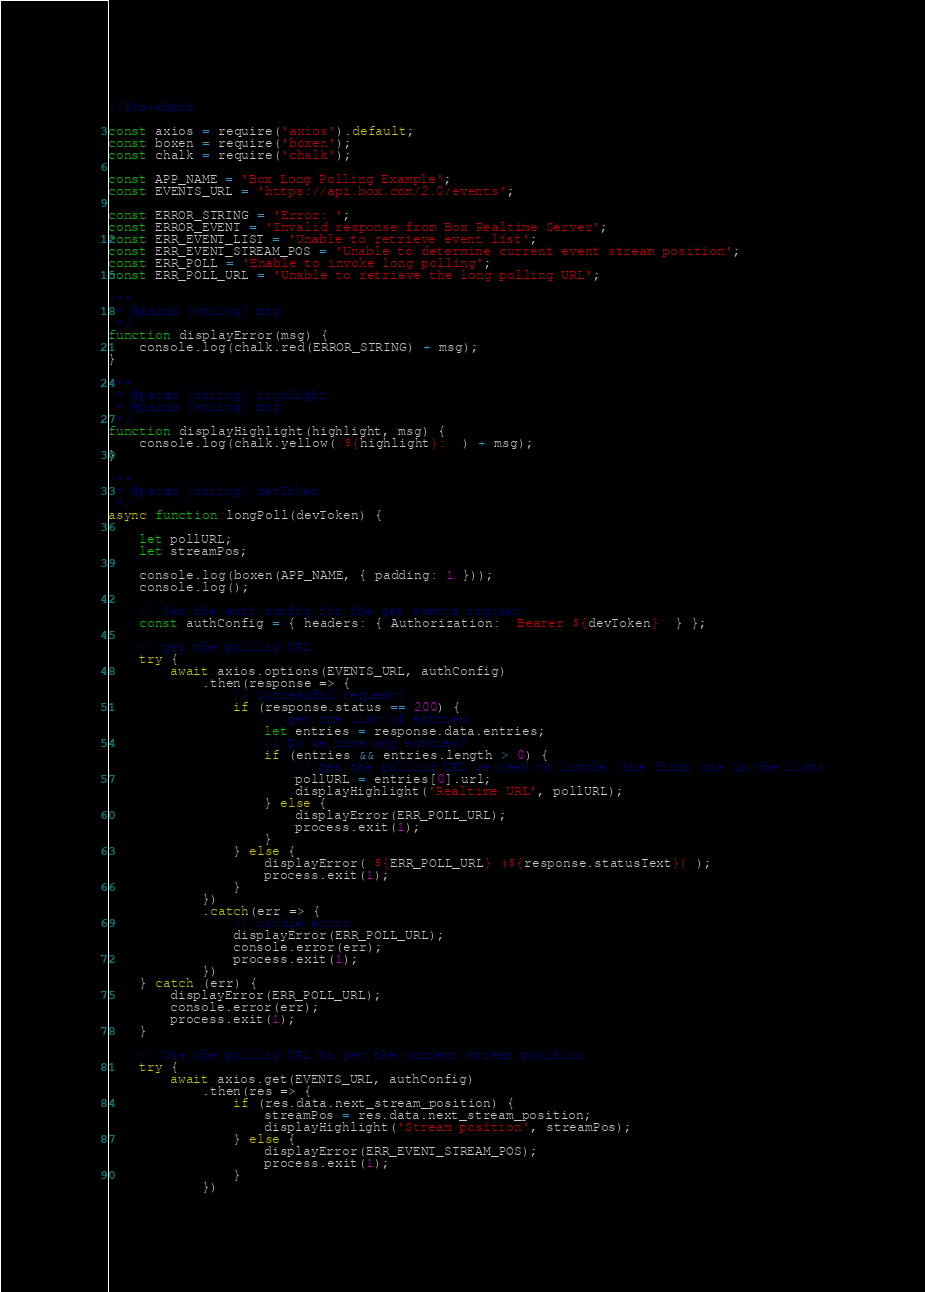Convert code to text. <code><loc_0><loc_0><loc_500><loc_500><_JavaScript_>//@ts-check

const axios = require('axios').default;
const boxen = require('boxen');
const chalk = require('chalk');

const APP_NAME = 'Box Long Polling Example';
const EVENTS_URL = 'https://api.box.com/2.0/events';

const ERROR_STRING = 'Error: ';
const ERROR_EVENT = 'Invalid response from Box Realtime Server';
const ERR_EVENT_LIST = 'Unable to retrieve event list';
const ERR_EVENT_STREAM_POS = 'Unable to determine current event stream position';
const ERR_POLL = 'Enable to invoke long polling';
const ERR_POLL_URL = 'Unable to retrieve the long polling URL';

/**
 * @param {string} msg 
 */
function displayError(msg) {
    console.log(chalk.red(ERROR_STRING) + msg);
}

/**
 * @param {string} highlight
 * @param {string} msg 
 */
function displayHighlight(highlight, msg) {
    console.log(chalk.yellow(`${highlight}: `) + msg);
}

/**
 * @param {string} devToken 
 */
async function longPoll(devToken) {

    let pollURL;
    let streamPos;

    console.log(boxen(APP_NAME, { padding: 1 }));
    console.log();

    // Set the auth config for the get events request
    const authConfig = { headers: { Authorization: `Bearer ${devToken}` } };

    // get the polling URL
    try {
        await axios.options(EVENTS_URL, authConfig)
            .then(response => {
                // Successful request?
                if (response.status == 200) {
                    // get the list of entries
                    let entries = response.data.entries;
                    // Do we have any entries?
                    if (entries && entries.length > 0) {
                        // get the polling URL we need to invoke (the first one in the list)
                        pollURL = entries[0].url;
                        displayHighlight('Realtime URL', pollURL);
                    } else {
                        displayError(ERR_POLL_URL);
                        process.exit(1);
                    }
                } else {
                    displayError(`${ERR_POLL_URL} (${response.statusText})`);
                    process.exit(1);
                }
            })
            .catch(err => {
                // handle error
                displayError(ERR_POLL_URL);
                console.error(err);
                process.exit(1);
            })
    } catch (err) {
        displayError(ERR_POLL_URL);
        console.error(err);
        process.exit(1);
    }

    // Use the polling URL to get the current stream position
    try {
        await axios.get(EVENTS_URL, authConfig)
            .then(res => {
                if (res.data.next_stream_position) {
                    streamPos = res.data.next_stream_position;
                    displayHighlight('Stream position', streamPos);
                } else {
                    displayError(ERR_EVENT_STREAM_POS);
                    process.exit(1);
                }
            })</code> 